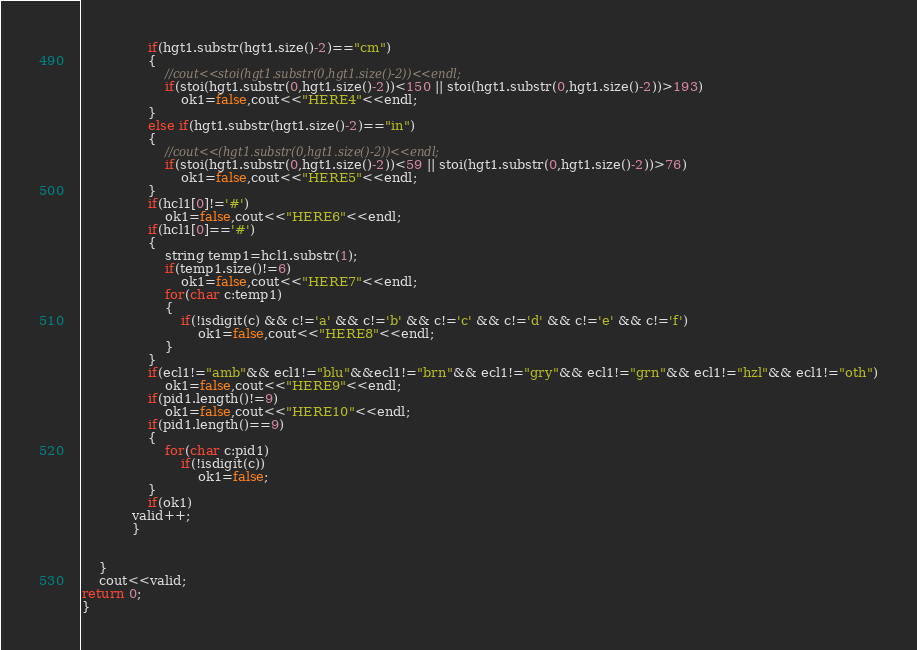Convert code to text. <code><loc_0><loc_0><loc_500><loc_500><_C++_>                if(hgt1.substr(hgt1.size()-2)=="cm")
                {
                    //cout<<stoi(hgt1.substr(0,hgt1.size()-2))<<endl;
                    if(stoi(hgt1.substr(0,hgt1.size()-2))<150 || stoi(hgt1.substr(0,hgt1.size()-2))>193)
                        ok1=false,cout<<"HERE4"<<endl;
                }
                else if(hgt1.substr(hgt1.size()-2)=="in")
                {
                    //cout<<(hgt1.substr(0,hgt1.size()-2))<<endl;
                    if(stoi(hgt1.substr(0,hgt1.size()-2))<59 || stoi(hgt1.substr(0,hgt1.size()-2))>76)
                        ok1=false,cout<<"HERE5"<<endl;
                }
                if(hcl1[0]!='#')
                    ok1=false,cout<<"HERE6"<<endl;
                if(hcl1[0]=='#')
                {
                    string temp1=hcl1.substr(1);
                    if(temp1.size()!=6)
                        ok1=false,cout<<"HERE7"<<endl;
                    for(char c:temp1)
                    {
                        if(!isdigit(c) && c!='a' && c!='b' && c!='c' && c!='d' && c!='e' && c!='f')
                            ok1=false,cout<<"HERE8"<<endl;
                    }
                }
                if(ecl1!="amb"&& ecl1!="blu"&&ecl1!="brn"&& ecl1!="gry"&& ecl1!="grn"&& ecl1!="hzl"&& ecl1!="oth")
                    ok1=false,cout<<"HERE9"<<endl;
                if(pid1.length()!=9)
                    ok1=false,cout<<"HERE10"<<endl;
                if(pid1.length()==9)
                {
                    for(char c:pid1)
                        if(!isdigit(c))
                            ok1=false;
                }
                if(ok1)
            valid++;  
            }
              

    }
    cout<<valid;
return 0;
}</code> 